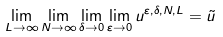<formula> <loc_0><loc_0><loc_500><loc_500>\lim _ { L \to \infty } \lim _ { N \to \infty } \lim _ { \delta \to 0 } \lim _ { \varepsilon \to 0 } u ^ { \varepsilon , \delta , N , L } = \tilde { u }</formula> 